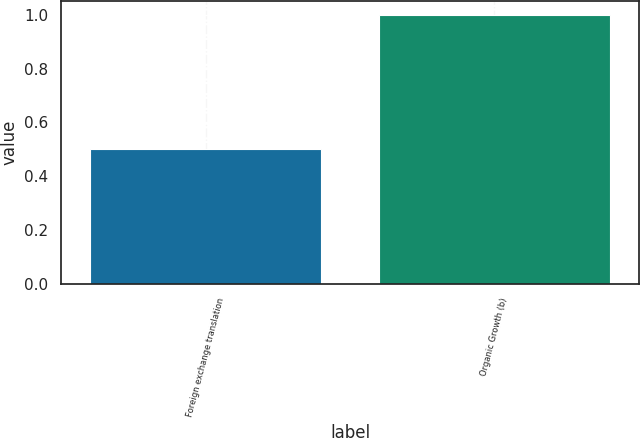<chart> <loc_0><loc_0><loc_500><loc_500><bar_chart><fcel>Foreign exchange translation<fcel>Organic Growth (b)<nl><fcel>0.5<fcel>1<nl></chart> 